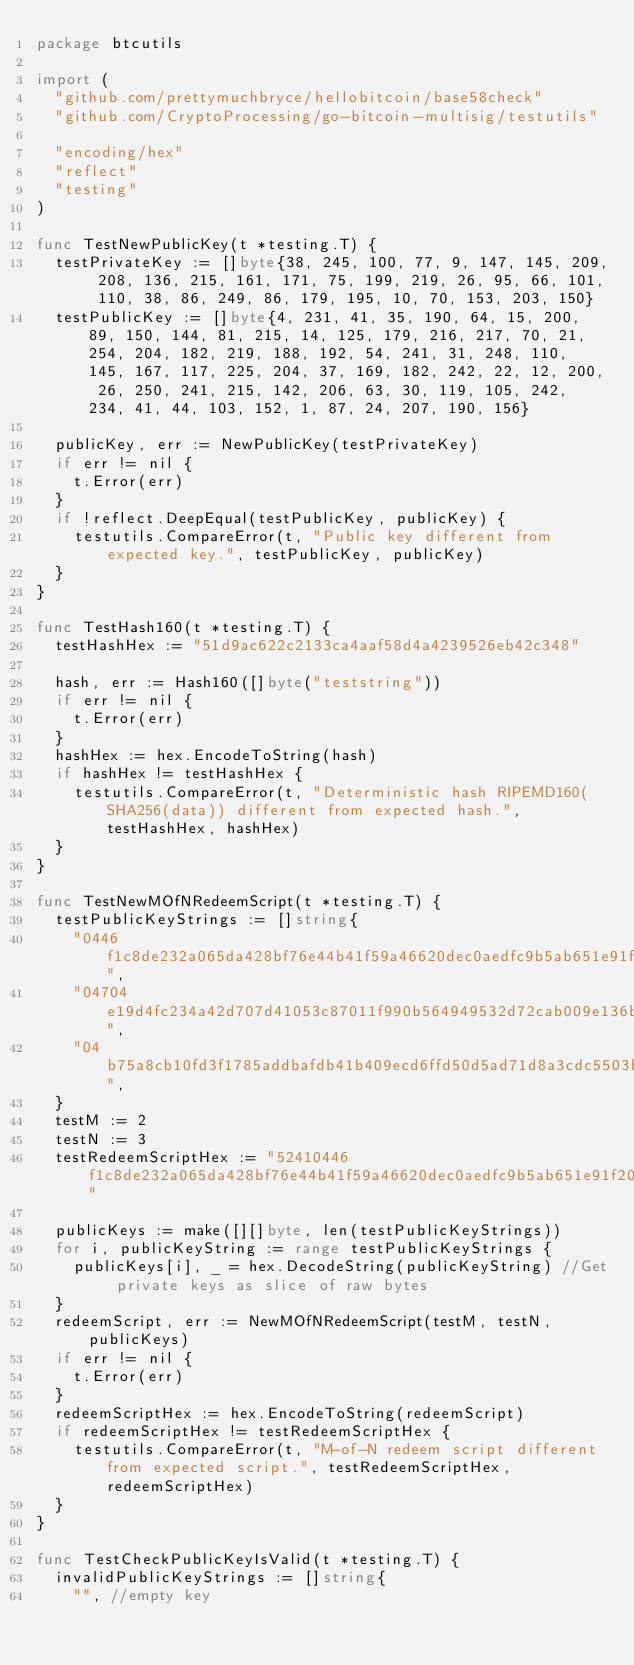<code> <loc_0><loc_0><loc_500><loc_500><_Go_>package btcutils

import (
	"github.com/prettymuchbryce/hellobitcoin/base58check"
	"github.com/CryptoProcessing/go-bitcoin-multisig/testutils"

	"encoding/hex"
	"reflect"
	"testing"
)

func TestNewPublicKey(t *testing.T) {
	testPrivateKey := []byte{38, 245, 100, 77, 9, 147, 145, 209, 208, 136, 215, 161, 171, 75, 199, 219, 26, 95, 66, 101, 110, 38, 86, 249, 86, 179, 195, 10, 70, 153, 203, 150}
	testPublicKey := []byte{4, 231, 41, 35, 190, 64, 15, 200, 89, 150, 144, 81, 215, 14, 125, 179, 216, 217, 70, 21, 254, 204, 182, 219, 188, 192, 54, 241, 31, 248, 110, 145, 167, 117, 225, 204, 37, 169, 182, 242, 22, 12, 200, 26, 250, 241, 215, 142, 206, 63, 30, 119, 105, 242, 234, 41, 44, 103, 152, 1, 87, 24, 207, 190, 156}

	publicKey, err := NewPublicKey(testPrivateKey)
	if err != nil {
		t.Error(err)
	}
	if !reflect.DeepEqual(testPublicKey, publicKey) {
		testutils.CompareError(t, "Public key different from expected key.", testPublicKey, publicKey)
	}
}

func TestHash160(t *testing.T) {
	testHashHex := "51d9ac622c2133ca4aaf58d4a4239526eb42c348"

	hash, err := Hash160([]byte("teststring"))
	if err != nil {
		t.Error(err)
	}
	hashHex := hex.EncodeToString(hash)
	if hashHex != testHashHex {
		testutils.CompareError(t, "Deterministic hash RIPEMD160(SHA256(data)) different from expected hash.", testHashHex, hashHex)
	}
}

func TestNewMOfNRedeemScript(t *testing.T) {
	testPublicKeyStrings := []string{
		"0446f1c8de232a065da428bf76e44b41f59a46620dec0aedfc9b5ab651e91f2051d610fddc78b8eba38a634bfe9a74bb015a88c52b9b844c74997035e08a695ce9",
		"04704e19d4fc234a42d707d41053c87011f990b564949532d72cab009e136bd60d7d0602f925fce79da77c0dfef4a49c6f44bd0540faef548e37557d74b36da124",
		"04b75a8cb10fd3f1785addbafdb41b409ecd6ffd50d5ad71d8a3cdc5503bcb35d3d13cdf23f6d0eb6ab88446276e2ba5b92d8786da7e5c0fb63aafb62f87443d28",
	}
	testM := 2
	testN := 3
	testRedeemScriptHex := "52410446f1c8de232a065da428bf76e44b41f59a46620dec0aedfc9b5ab651e91f2051d610fddc78b8eba38a634bfe9a74bb015a88c52b9b844c74997035e08a695ce94104704e19d4fc234a42d707d41053c87011f990b564949532d72cab009e136bd60d7d0602f925fce79da77c0dfef4a49c6f44bd0540faef548e37557d74b36da1244104b75a8cb10fd3f1785addbafdb41b409ecd6ffd50d5ad71d8a3cdc5503bcb35d3d13cdf23f6d0eb6ab88446276e2ba5b92d8786da7e5c0fb63aafb62f87443d2853ae"

	publicKeys := make([][]byte, len(testPublicKeyStrings))
	for i, publicKeyString := range testPublicKeyStrings {
		publicKeys[i], _ = hex.DecodeString(publicKeyString) //Get private keys as slice of raw bytes
	}
	redeemScript, err := NewMOfNRedeemScript(testM, testN, publicKeys)
	if err != nil {
		t.Error(err)
	}
	redeemScriptHex := hex.EncodeToString(redeemScript)
	if redeemScriptHex != testRedeemScriptHex {
		testutils.CompareError(t, "M-of-N redeem script different from expected script.", testRedeemScriptHex, redeemScriptHex)
	}
}

func TestCheckPublicKeyIsValid(t *testing.T) {
	invalidPublicKeyStrings := []string{
		"", //empty key</code> 